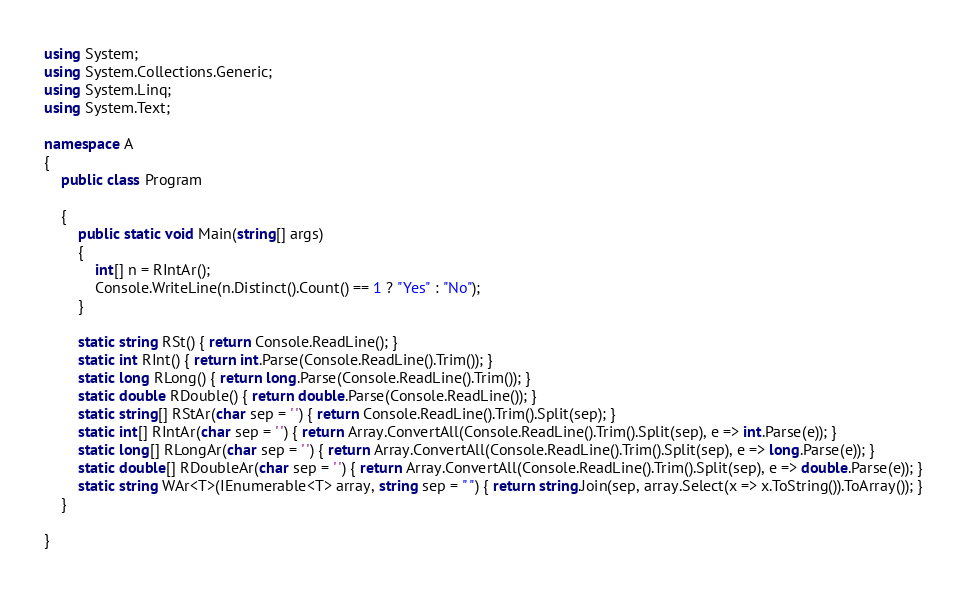<code> <loc_0><loc_0><loc_500><loc_500><_C#_>using System;
using System.Collections.Generic;
using System.Linq;
using System.Text;

namespace A
{
    public class Program

    {
        public static void Main(string[] args)
        {
            int[] n = RIntAr();
            Console.WriteLine(n.Distinct().Count() == 1 ? "Yes" : "No");
        }

        static string RSt() { return Console.ReadLine(); }
        static int RInt() { return int.Parse(Console.ReadLine().Trim()); }
        static long RLong() { return long.Parse(Console.ReadLine().Trim()); }
        static double RDouble() { return double.Parse(Console.ReadLine()); }
        static string[] RStAr(char sep = ' ') { return Console.ReadLine().Trim().Split(sep); }
        static int[] RIntAr(char sep = ' ') { return Array.ConvertAll(Console.ReadLine().Trim().Split(sep), e => int.Parse(e)); }
        static long[] RLongAr(char sep = ' ') { return Array.ConvertAll(Console.ReadLine().Trim().Split(sep), e => long.Parse(e)); }
        static double[] RDoubleAr(char sep = ' ') { return Array.ConvertAll(Console.ReadLine().Trim().Split(sep), e => double.Parse(e)); }
        static string WAr<T>(IEnumerable<T> array, string sep = " ") { return string.Join(sep, array.Select(x => x.ToString()).ToArray()); }
    }

}
</code> 